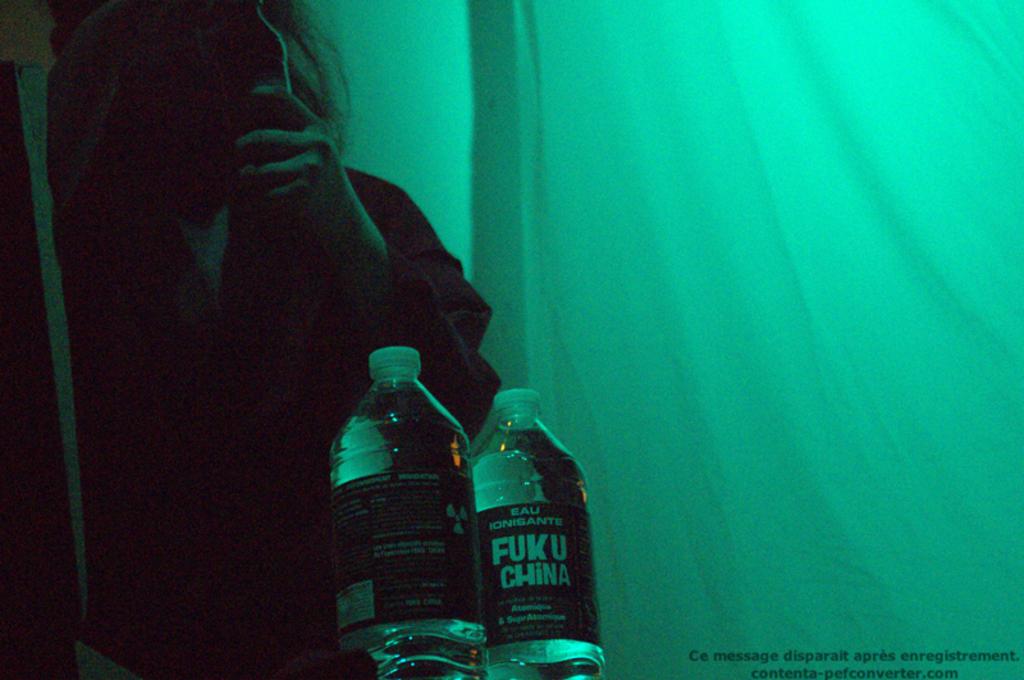What does that say on the water label?
Your response must be concise. Fuku china. 